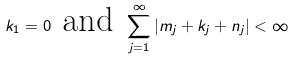<formula> <loc_0><loc_0><loc_500><loc_500>k _ { 1 } = 0 \text { and } \sum _ { j = 1 } ^ { \infty } | m _ { j } + k _ { j } + n _ { j } | < \infty</formula> 